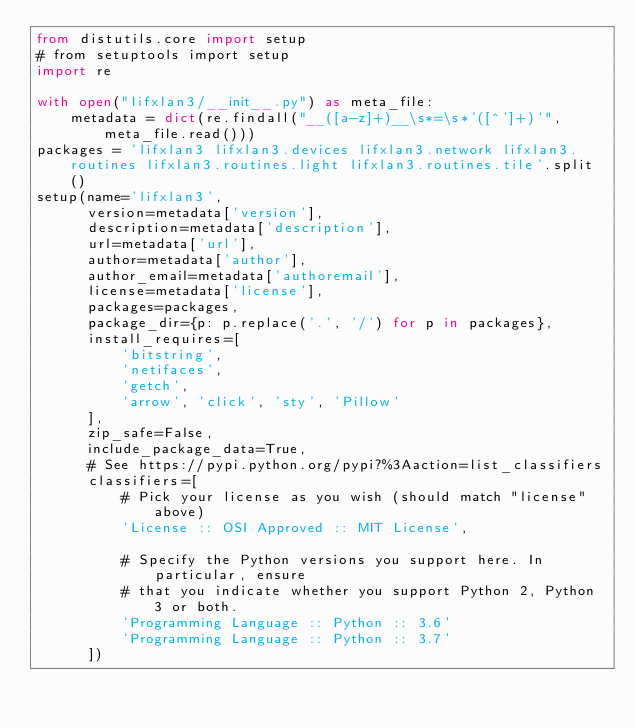<code> <loc_0><loc_0><loc_500><loc_500><_Python_>from distutils.core import setup
# from setuptools import setup
import re

with open("lifxlan3/__init__.py") as meta_file:
    metadata = dict(re.findall("__([a-z]+)__\s*=\s*'([^']+)'", meta_file.read()))
packages = 'lifxlan3 lifxlan3.devices lifxlan3.network lifxlan3.routines lifxlan3.routines.light lifxlan3.routines.tile'.split()
setup(name='lifxlan3',
      version=metadata['version'],
      description=metadata['description'],
      url=metadata['url'],
      author=metadata['author'],
      author_email=metadata['authoremail'],
      license=metadata['license'],
      packages=packages,
      package_dir={p: p.replace('.', '/') for p in packages},
      install_requires=[
          'bitstring',
          'netifaces',
          'getch',
          'arrow', 'click', 'sty', 'Pillow'
      ],
      zip_safe=False,
      include_package_data=True,
      # See https://pypi.python.org/pypi?%3Aaction=list_classifiers
      classifiers=[
          # Pick your license as you wish (should match "license" above)
          'License :: OSI Approved :: MIT License',

          # Specify the Python versions you support here. In particular, ensure
          # that you indicate whether you support Python 2, Python 3 or both.
          'Programming Language :: Python :: 3.6'
          'Programming Language :: Python :: 3.7'
      ])
</code> 